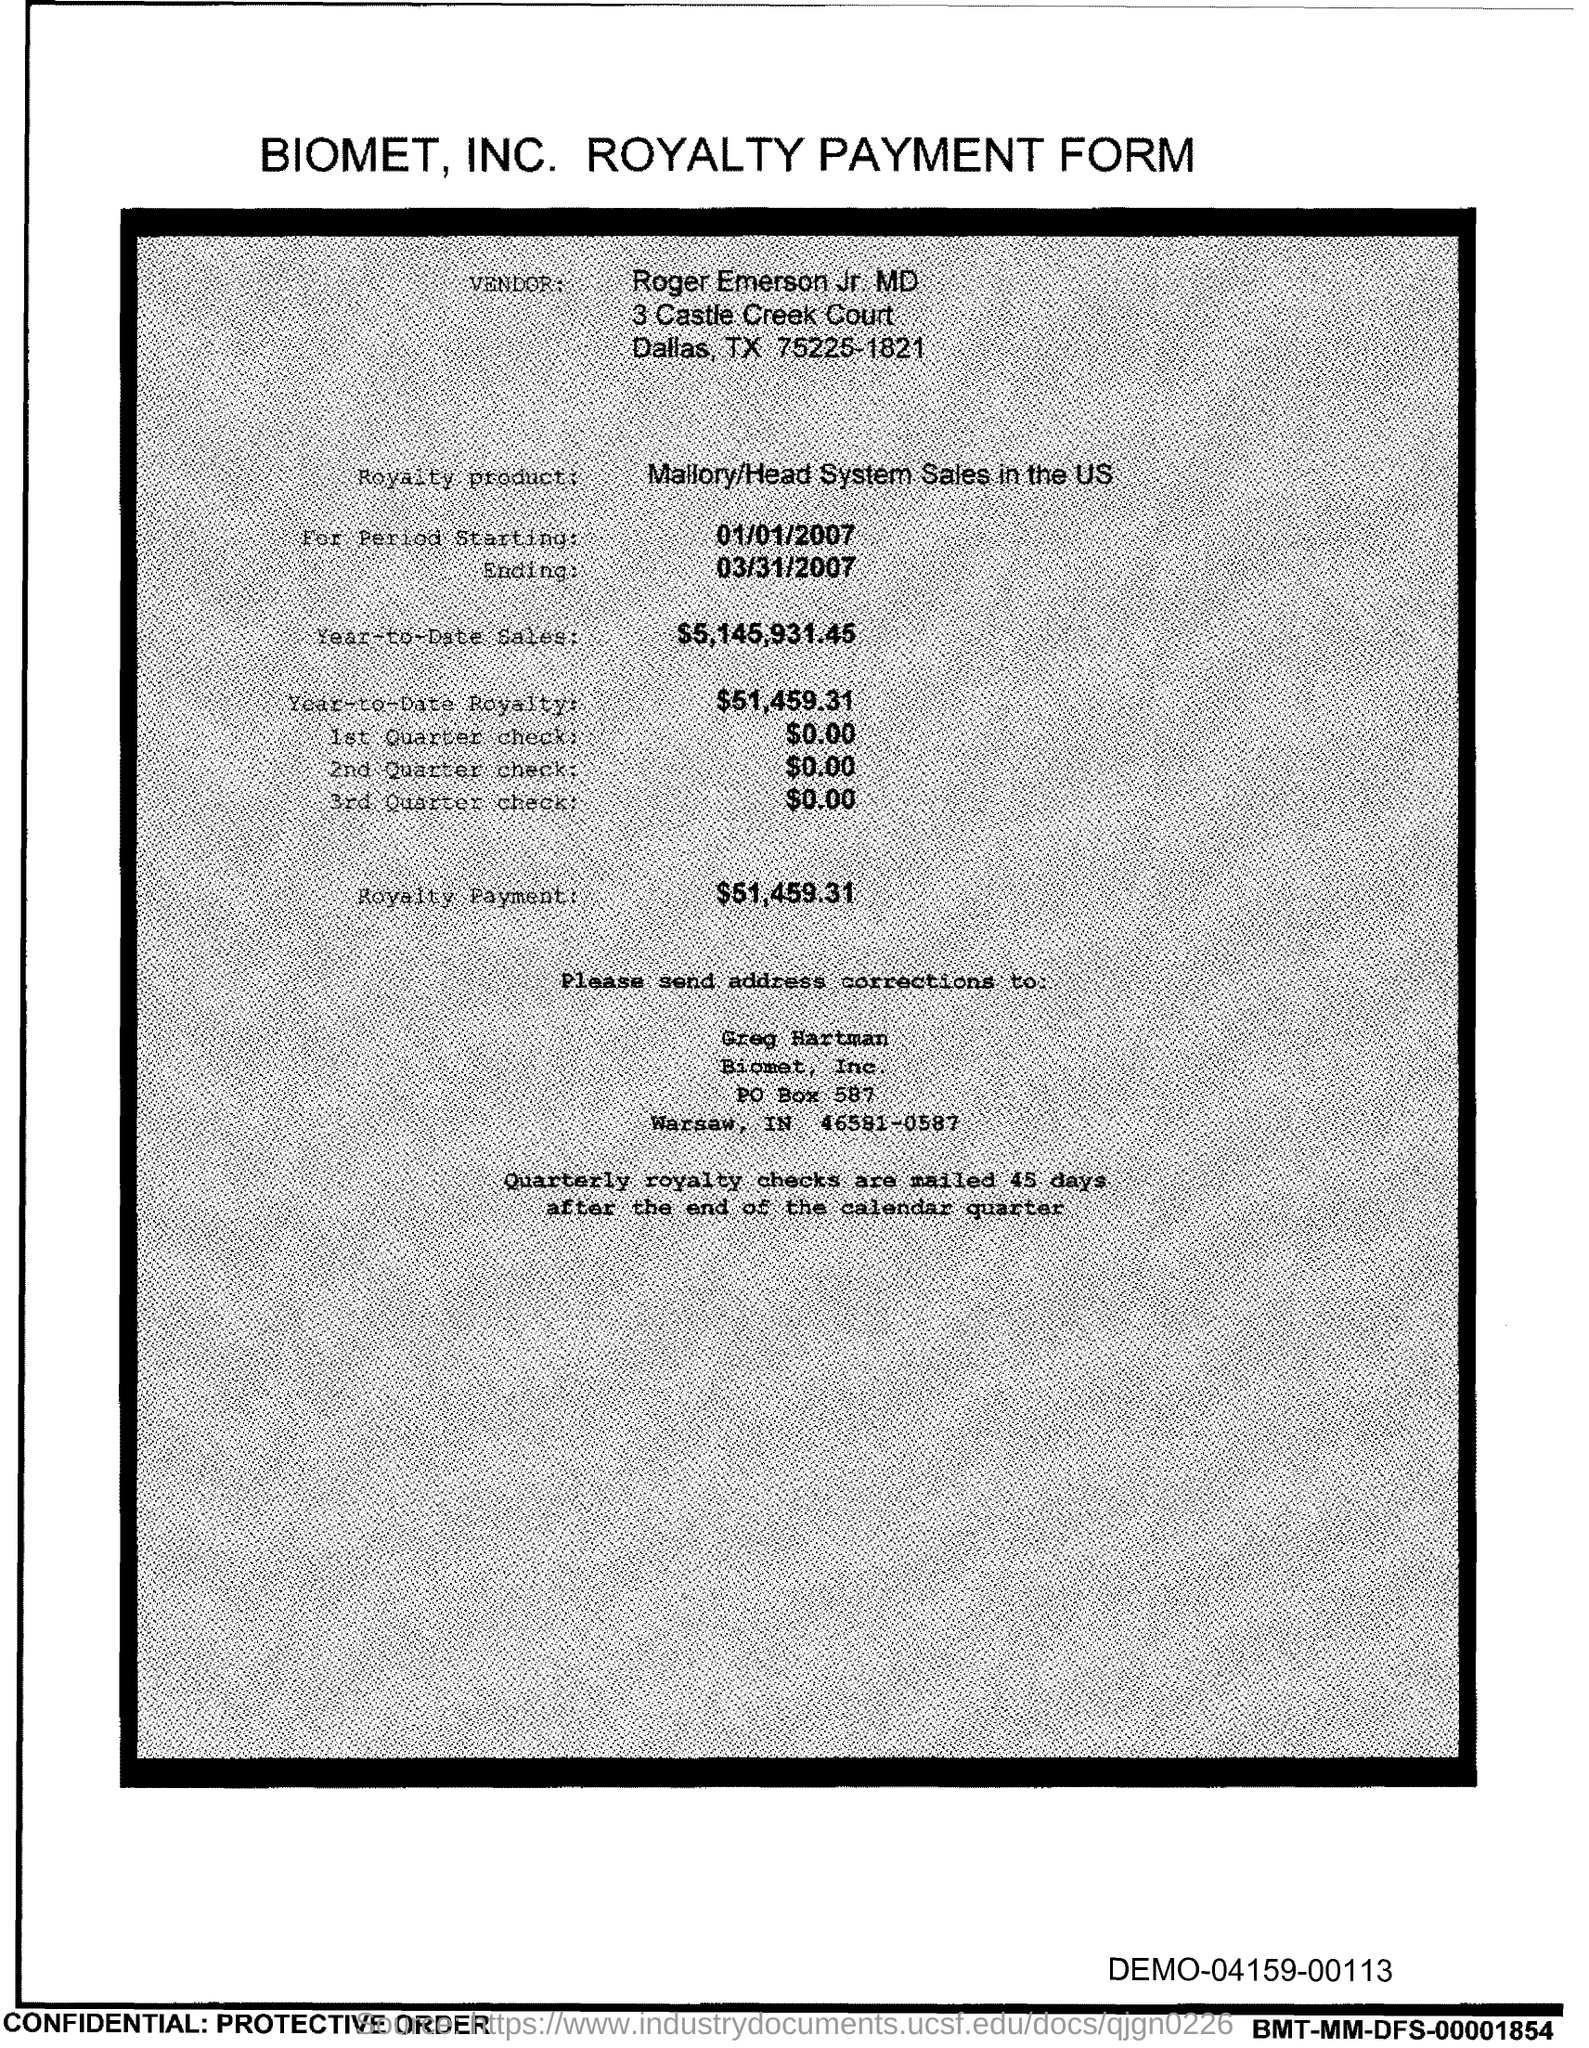Identify some key points in this picture. The year-to-date sales as of today are $5,145,931.45. The royalty payment is $51,459.31. The year-to-date royalty is $51,459.31. The date for period starting from 01/01/2007 has not been specified. The date for ending is March 31, 2007. 